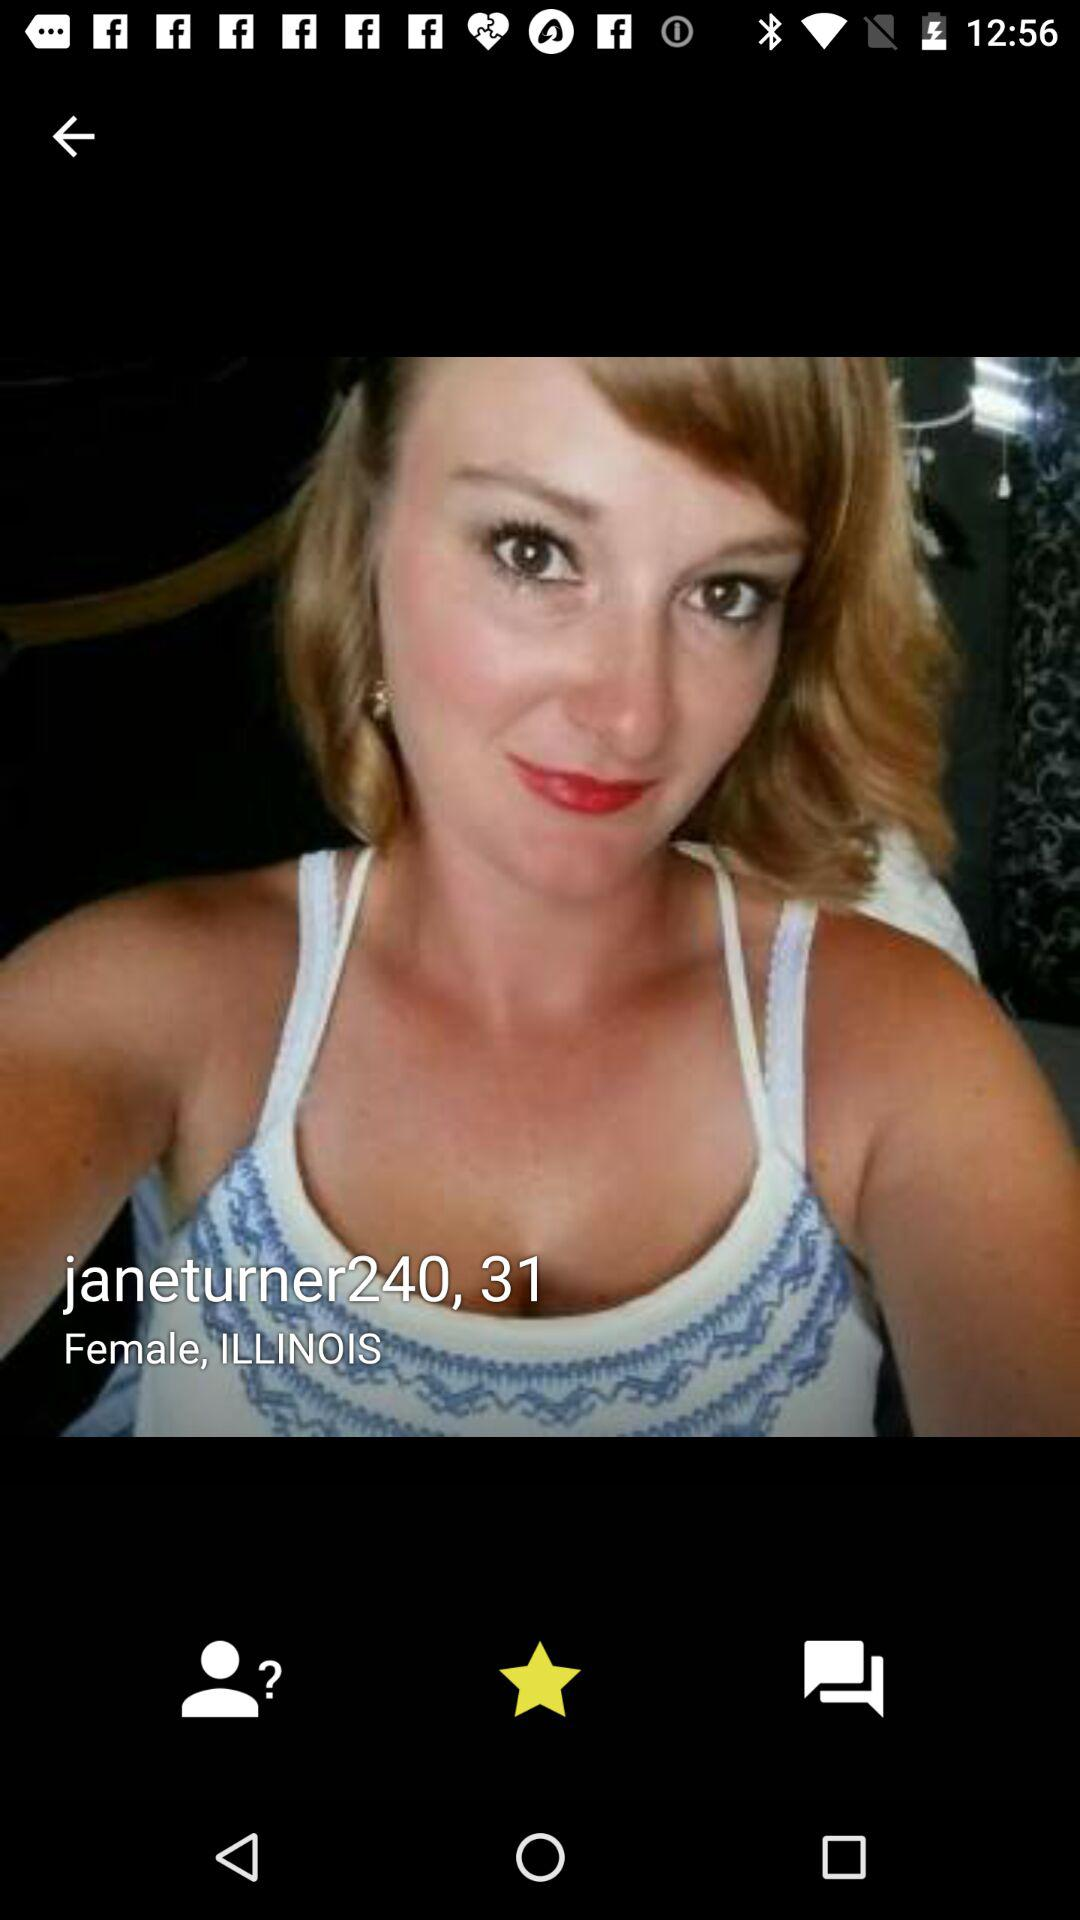What is the username? The username is "janeturner240". 